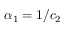Convert formula to latex. <formula><loc_0><loc_0><loc_500><loc_500>{ \alpha _ { 1 } = 1 / c _ { 2 } }</formula> 